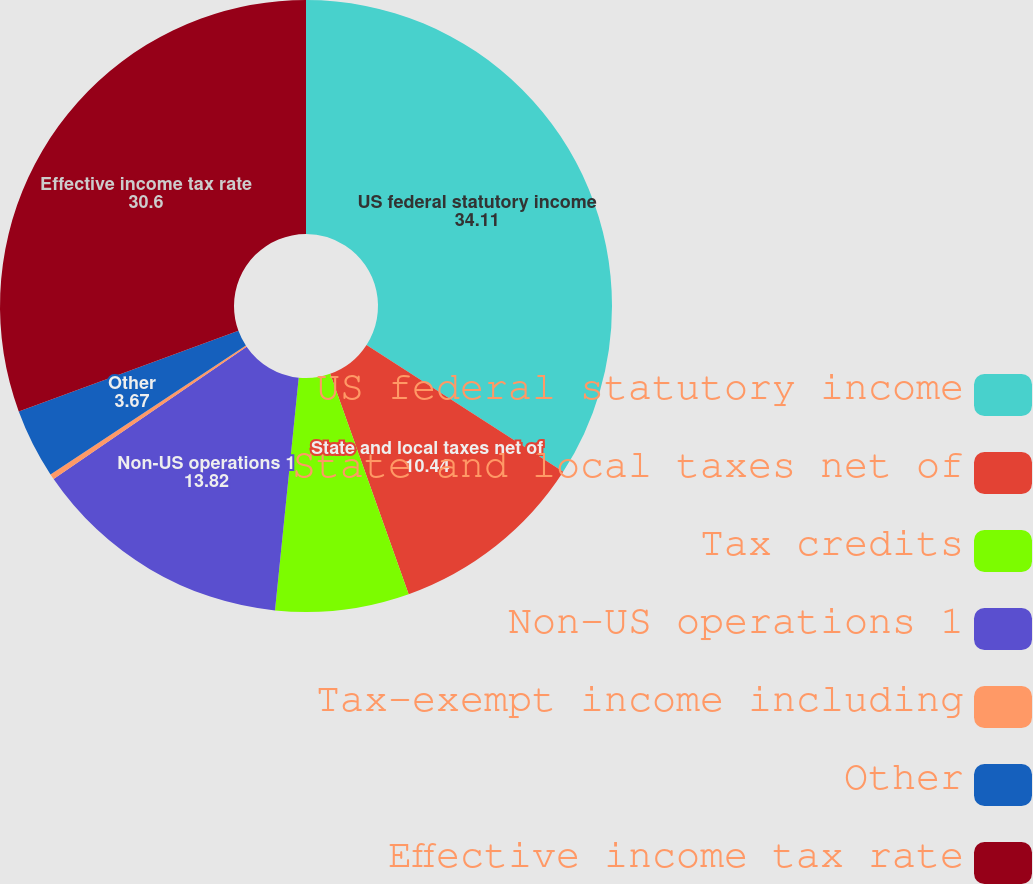Convert chart. <chart><loc_0><loc_0><loc_500><loc_500><pie_chart><fcel>US federal statutory income<fcel>State and local taxes net of<fcel>Tax credits<fcel>Non-US operations 1<fcel>Tax-exempt income including<fcel>Other<fcel>Effective income tax rate<nl><fcel>34.11%<fcel>10.44%<fcel>7.06%<fcel>13.82%<fcel>0.29%<fcel>3.67%<fcel>30.6%<nl></chart> 